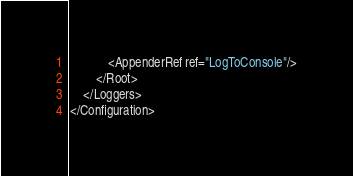<code> <loc_0><loc_0><loc_500><loc_500><_XML_>            <AppenderRef ref="LogToConsole"/>
        </Root>
    </Loggers>
</Configuration>
</code> 